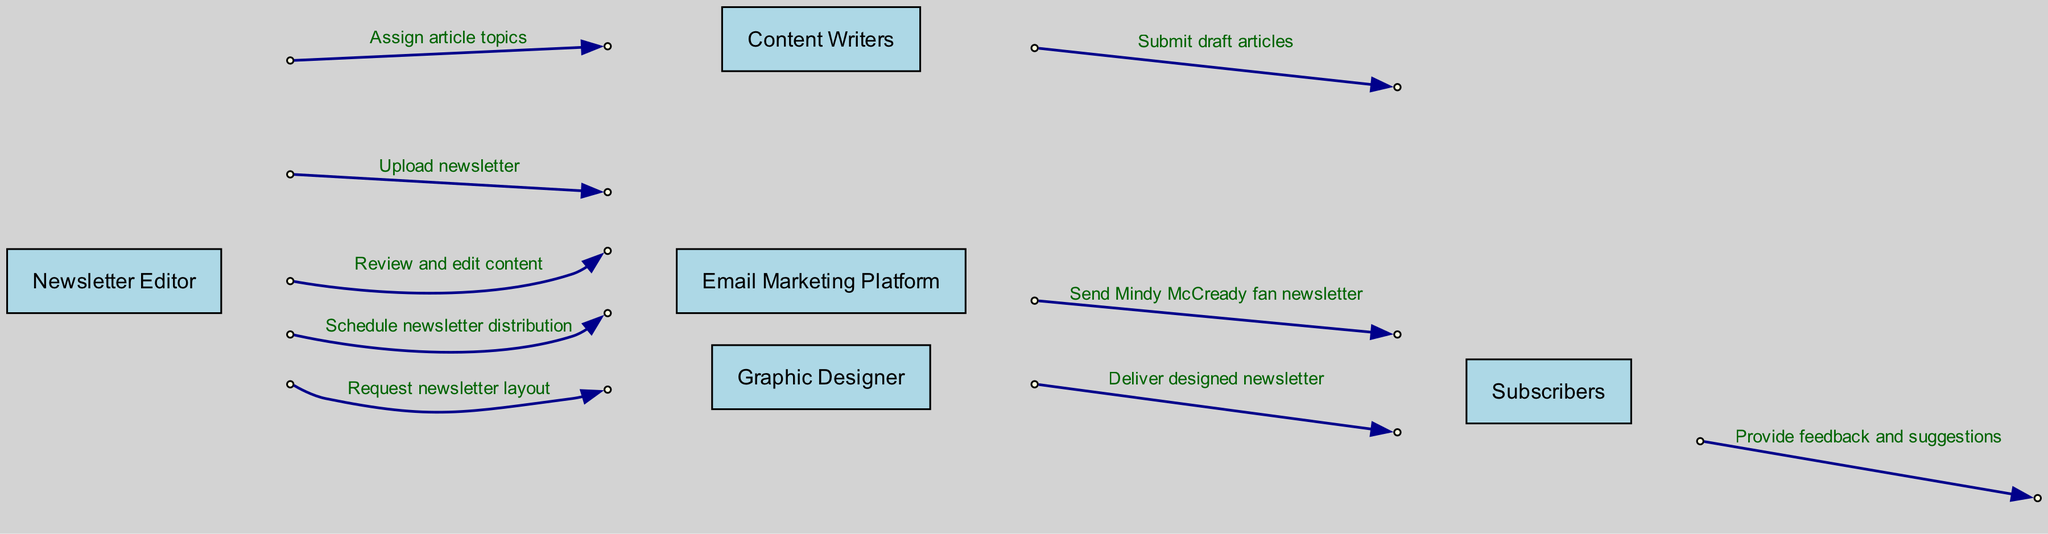What is the first action taken in the sequence? The first action is when the Newsletter Editor assigns article topics to the Content Writers. This step starts the process of newsletter creation.
Answer: Assign article topics How many actors are involved in the sequence? There are five actors involved in the sequence: Newsletter Editor, Content Writers, Graphic Designer, Email Marketing Platform, and Subscribers. Counting these gives a total of five.
Answer: 5 Which actor submits draft articles? The Content Writers submit draft articles to the Newsletter Editor. This indicates the role of Content Writers in the content creation process.
Answer: Content Writers What message is sent from the Email Marketing Platform to Subscribers? The Email Marketing Platform sends the message "Send Mindy McCready fan newsletter" to the Subscribers, indicating the final output of the newsletter process.
Answer: Send Mindy McCready fan newsletter What is the purpose of the step where the Newsletter Editor reviews and edits content? The purpose of this step is to ensure that the articles submitted by the Content Writers are polished and ready for the audience, contributing to the quality of the newsletter.
Answer: Review and edit content Which actor receives feedback from Subscribers? The Newsletter Editor receives feedback and suggestions from the Subscribers, indicating a loop back to the content creator for future improvements.
Answer: Newsletter Editor How does the Graphic Designer interact with the Newsletter Editor? The Graphic Designer delivers the designed newsletter to the Newsletter Editor, completing the layout phase of the newsletter's creation process.
Answer: Deliver designed newsletter What is the final step in the sequence? The final step in the sequence is when the Email Marketing Platform sends the newsletter to the Subscribers, concluding the entire distribution process.
Answer: Send Mindy McCready fan newsletter How many messages are exchanged between the Newsletter Editor and Email Marketing Platform? There are two messages exchanged: first, uploading the newsletter, and second, scheduling the newsletter distribution. Thus, the total is two messages.
Answer: 2 